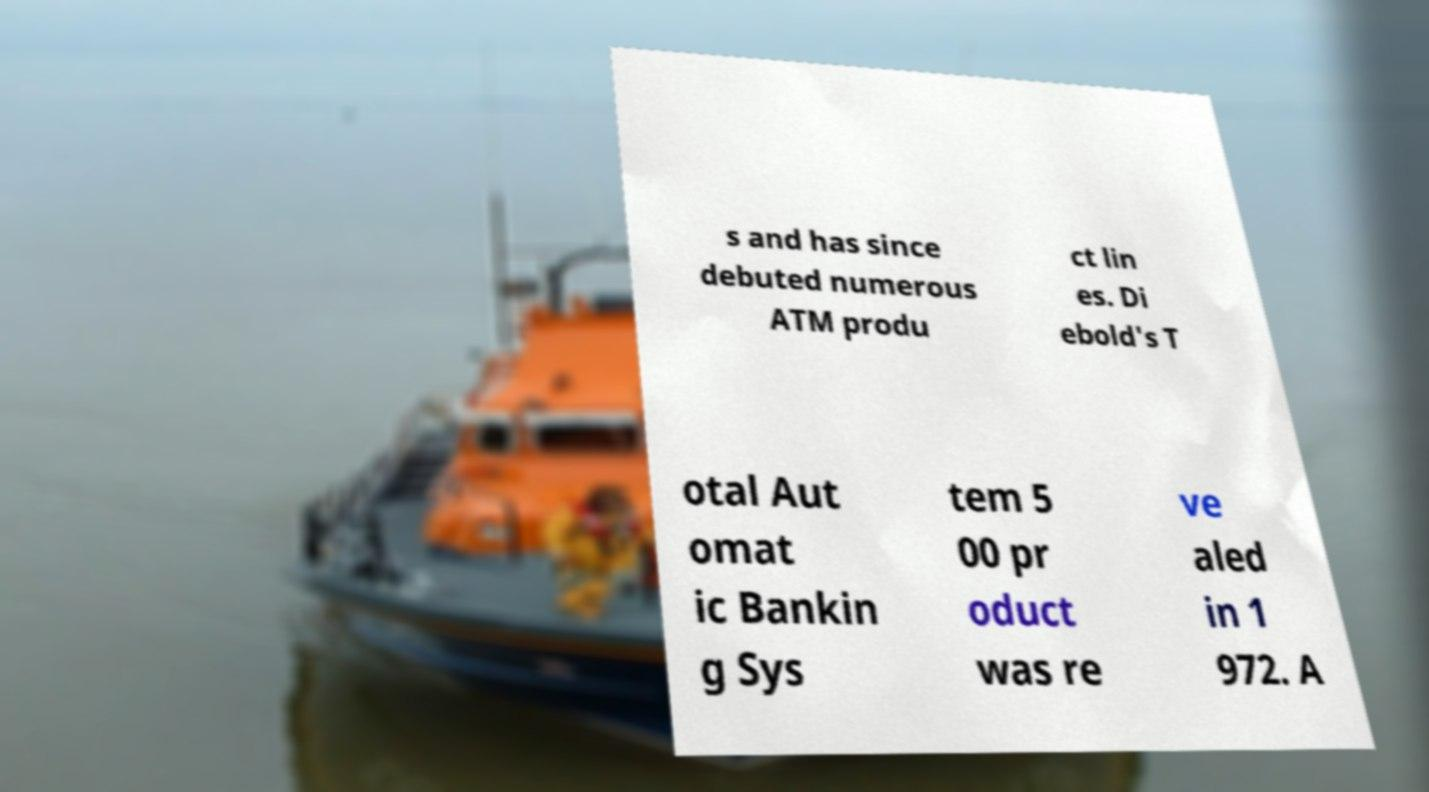Could you assist in decoding the text presented in this image and type it out clearly? s and has since debuted numerous ATM produ ct lin es. Di ebold's T otal Aut omat ic Bankin g Sys tem 5 00 pr oduct was re ve aled in 1 972. A 